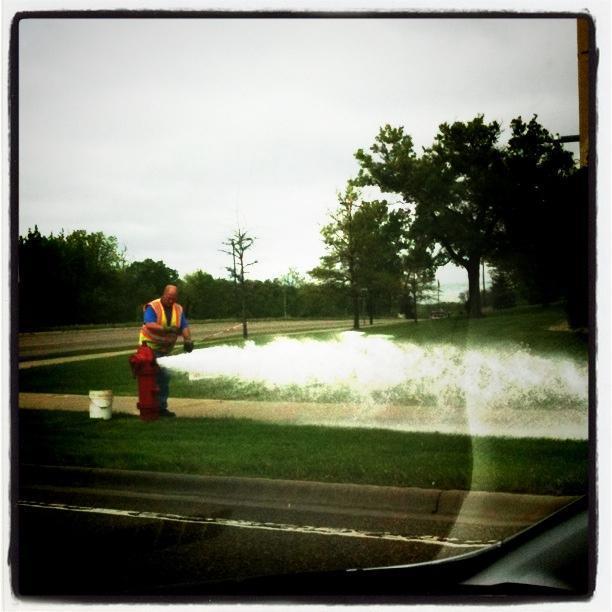How many people are in the scene?
Give a very brief answer. 1. How many people are in the picture?
Give a very brief answer. 1. How many colorful umbrellas are there?
Give a very brief answer. 0. 